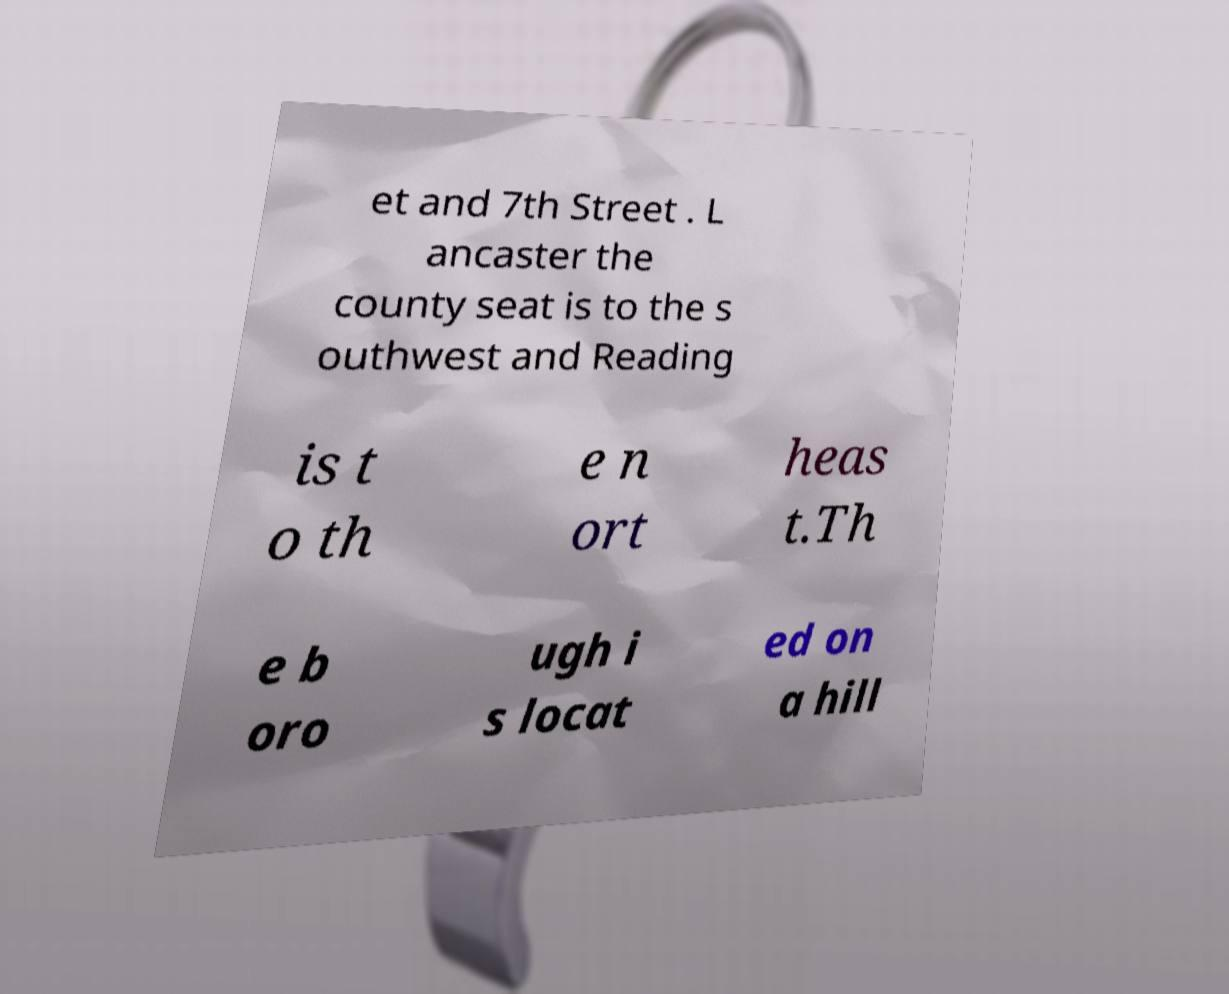Can you accurately transcribe the text from the provided image for me? et and 7th Street . L ancaster the county seat is to the s outhwest and Reading is t o th e n ort heas t.Th e b oro ugh i s locat ed on a hill 